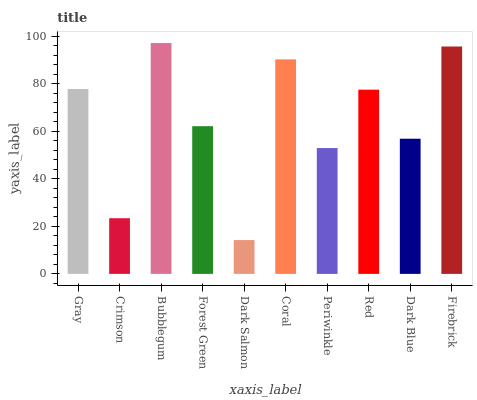Is Dark Salmon the minimum?
Answer yes or no. Yes. Is Bubblegum the maximum?
Answer yes or no. Yes. Is Crimson the minimum?
Answer yes or no. No. Is Crimson the maximum?
Answer yes or no. No. Is Gray greater than Crimson?
Answer yes or no. Yes. Is Crimson less than Gray?
Answer yes or no. Yes. Is Crimson greater than Gray?
Answer yes or no. No. Is Gray less than Crimson?
Answer yes or no. No. Is Red the high median?
Answer yes or no. Yes. Is Forest Green the low median?
Answer yes or no. Yes. Is Gray the high median?
Answer yes or no. No. Is Firebrick the low median?
Answer yes or no. No. 